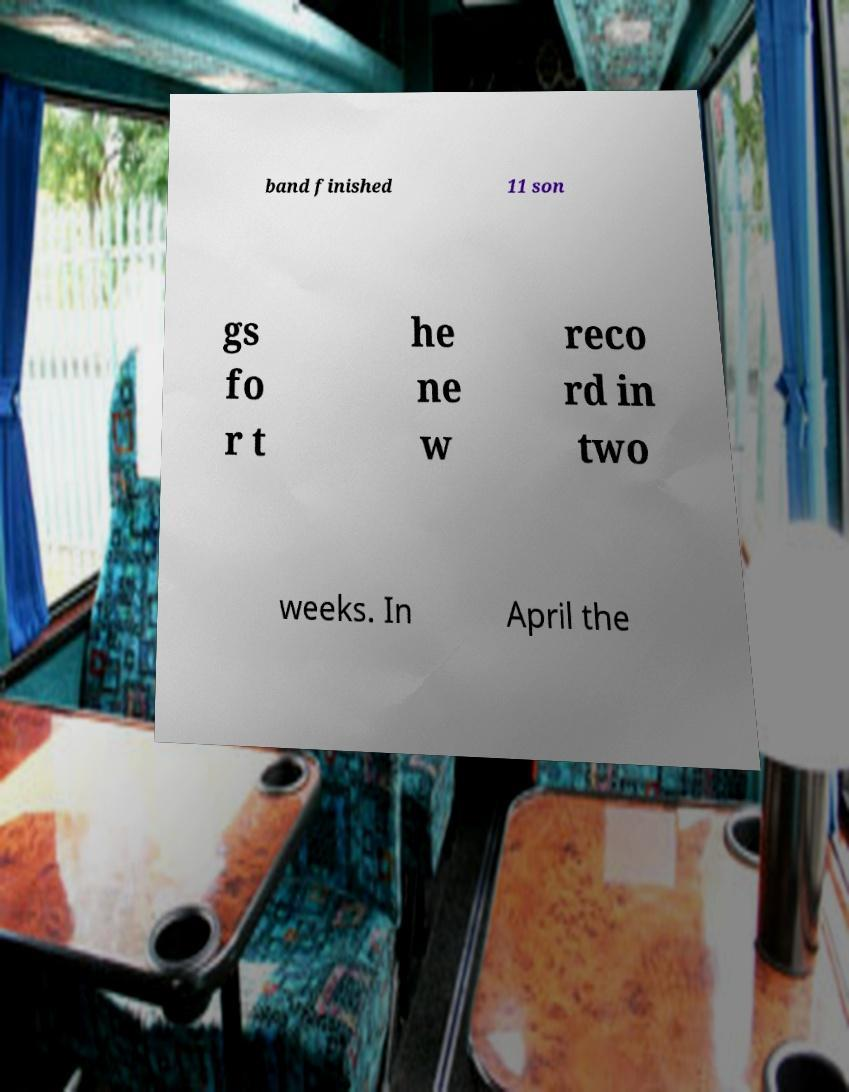For documentation purposes, I need the text within this image transcribed. Could you provide that? band finished 11 son gs fo r t he ne w reco rd in two weeks. In April the 